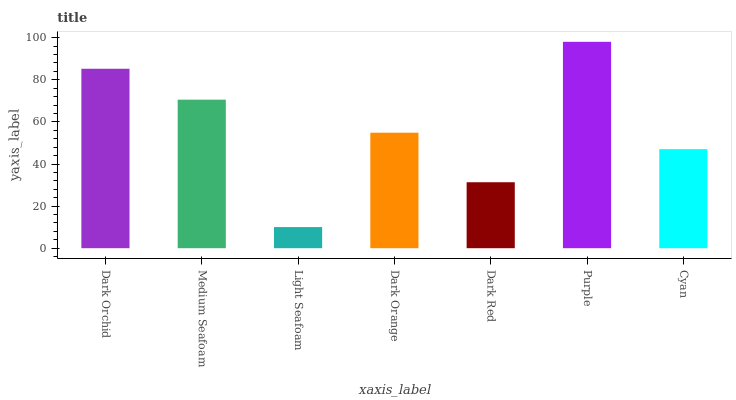Is Light Seafoam the minimum?
Answer yes or no. Yes. Is Purple the maximum?
Answer yes or no. Yes. Is Medium Seafoam the minimum?
Answer yes or no. No. Is Medium Seafoam the maximum?
Answer yes or no. No. Is Dark Orchid greater than Medium Seafoam?
Answer yes or no. Yes. Is Medium Seafoam less than Dark Orchid?
Answer yes or no. Yes. Is Medium Seafoam greater than Dark Orchid?
Answer yes or no. No. Is Dark Orchid less than Medium Seafoam?
Answer yes or no. No. Is Dark Orange the high median?
Answer yes or no. Yes. Is Dark Orange the low median?
Answer yes or no. Yes. Is Cyan the high median?
Answer yes or no. No. Is Dark Orchid the low median?
Answer yes or no. No. 